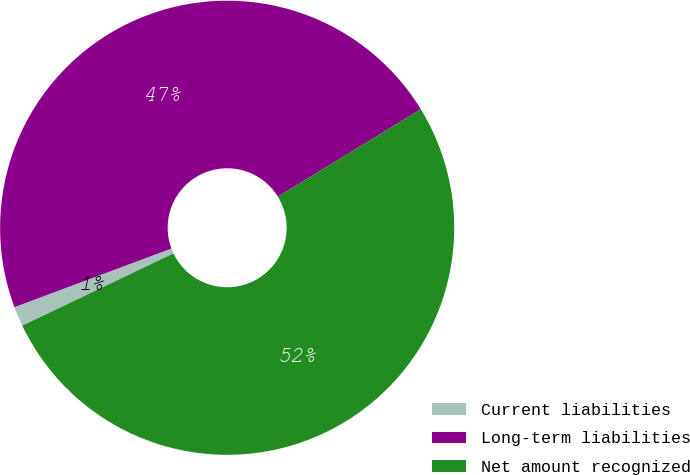<chart> <loc_0><loc_0><loc_500><loc_500><pie_chart><fcel>Current liabilities<fcel>Long-term liabilities<fcel>Net amount recognized<nl><fcel>1.41%<fcel>46.95%<fcel>51.64%<nl></chart> 